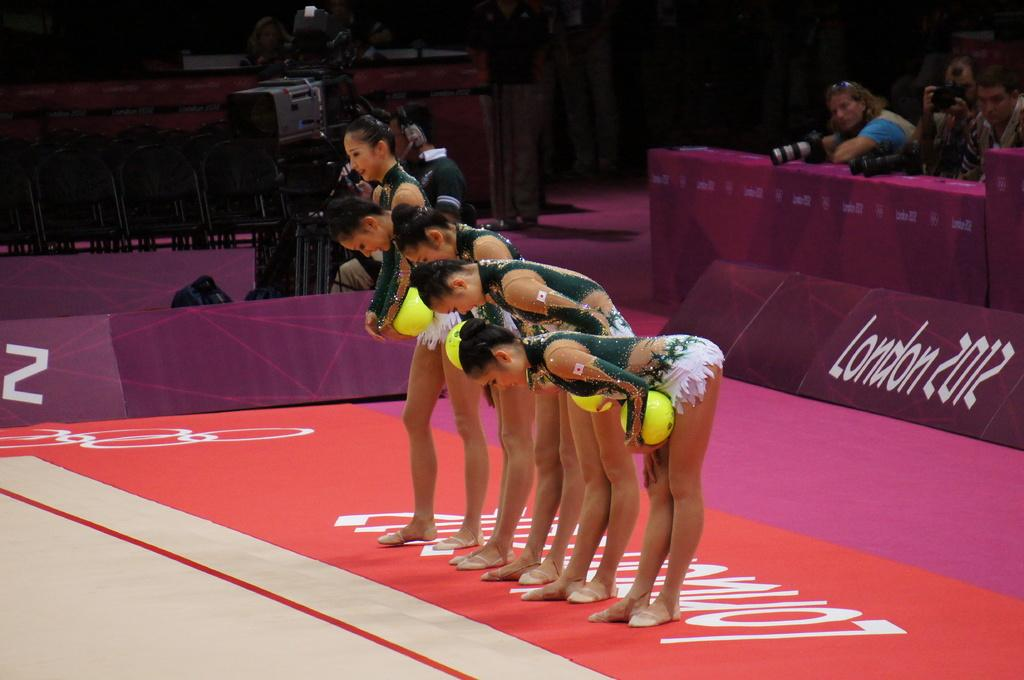<image>
Present a compact description of the photo's key features. An Asian team competes at the 2012 Olympics in London. 